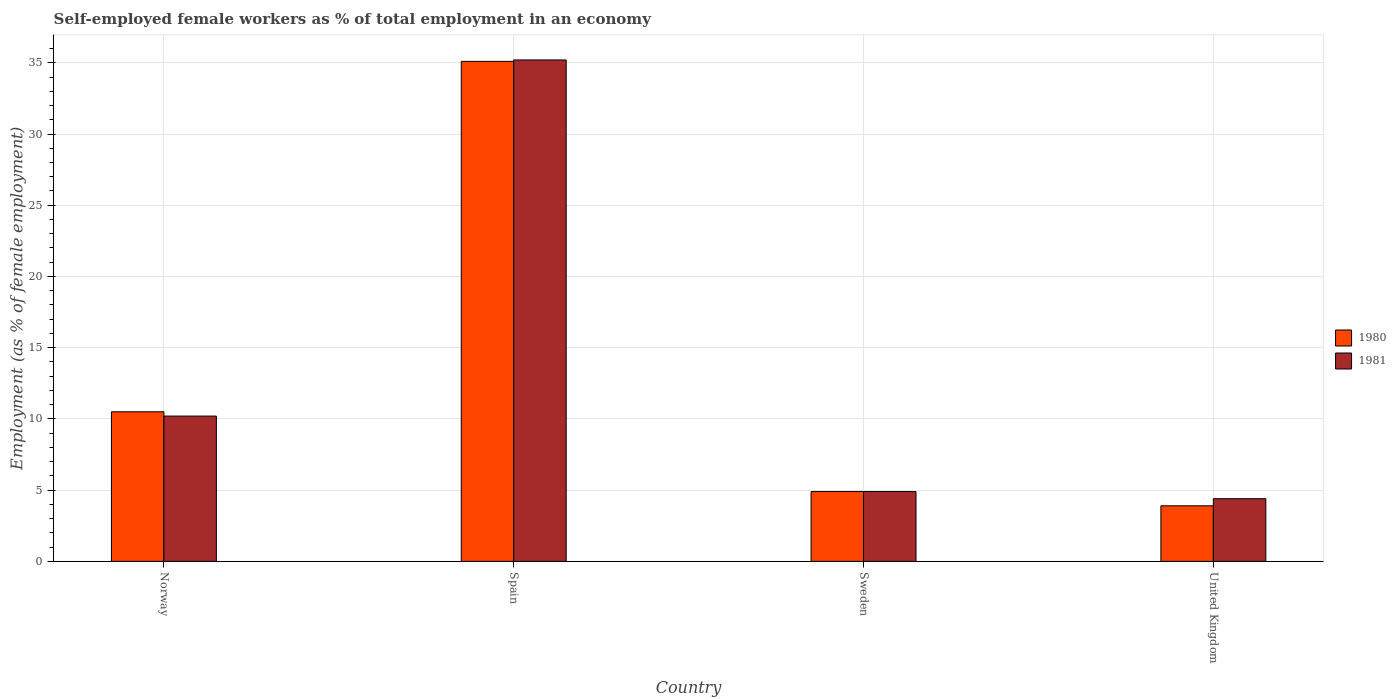How many groups of bars are there?
Your response must be concise. 4. Are the number of bars per tick equal to the number of legend labels?
Ensure brevity in your answer.  Yes. How many bars are there on the 3rd tick from the left?
Ensure brevity in your answer.  2. What is the label of the 4th group of bars from the left?
Provide a succinct answer. United Kingdom. What is the percentage of self-employed female workers in 1980 in United Kingdom?
Offer a very short reply. 3.9. Across all countries, what is the maximum percentage of self-employed female workers in 1981?
Make the answer very short. 35.2. Across all countries, what is the minimum percentage of self-employed female workers in 1980?
Give a very brief answer. 3.9. In which country was the percentage of self-employed female workers in 1981 minimum?
Give a very brief answer. United Kingdom. What is the total percentage of self-employed female workers in 1981 in the graph?
Your response must be concise. 54.7. What is the difference between the percentage of self-employed female workers in 1980 in Spain and that in Sweden?
Keep it short and to the point. 30.2. What is the difference between the percentage of self-employed female workers in 1980 in Sweden and the percentage of self-employed female workers in 1981 in Norway?
Offer a very short reply. -5.3. What is the average percentage of self-employed female workers in 1981 per country?
Make the answer very short. 13.68. What is the difference between the percentage of self-employed female workers of/in 1981 and percentage of self-employed female workers of/in 1980 in Norway?
Provide a short and direct response. -0.3. What is the ratio of the percentage of self-employed female workers in 1980 in Sweden to that in United Kingdom?
Your answer should be very brief. 1.26. What is the difference between the highest and the second highest percentage of self-employed female workers in 1981?
Make the answer very short. -25. What is the difference between the highest and the lowest percentage of self-employed female workers in 1980?
Provide a short and direct response. 31.2. What does the 1st bar from the left in Spain represents?
Provide a succinct answer. 1980. How many bars are there?
Your answer should be compact. 8. Are all the bars in the graph horizontal?
Ensure brevity in your answer.  No. How many countries are there in the graph?
Make the answer very short. 4. Does the graph contain grids?
Your response must be concise. Yes. How many legend labels are there?
Ensure brevity in your answer.  2. What is the title of the graph?
Your answer should be very brief. Self-employed female workers as % of total employment in an economy. Does "1965" appear as one of the legend labels in the graph?
Make the answer very short. No. What is the label or title of the Y-axis?
Your answer should be very brief. Employment (as % of female employment). What is the Employment (as % of female employment) of 1981 in Norway?
Keep it short and to the point. 10.2. What is the Employment (as % of female employment) of 1980 in Spain?
Your response must be concise. 35.1. What is the Employment (as % of female employment) in 1981 in Spain?
Keep it short and to the point. 35.2. What is the Employment (as % of female employment) in 1980 in Sweden?
Keep it short and to the point. 4.9. What is the Employment (as % of female employment) in 1981 in Sweden?
Provide a short and direct response. 4.9. What is the Employment (as % of female employment) in 1980 in United Kingdom?
Your answer should be compact. 3.9. What is the Employment (as % of female employment) in 1981 in United Kingdom?
Your answer should be very brief. 4.4. Across all countries, what is the maximum Employment (as % of female employment) of 1980?
Ensure brevity in your answer.  35.1. Across all countries, what is the maximum Employment (as % of female employment) of 1981?
Provide a succinct answer. 35.2. Across all countries, what is the minimum Employment (as % of female employment) in 1980?
Your answer should be compact. 3.9. Across all countries, what is the minimum Employment (as % of female employment) of 1981?
Offer a very short reply. 4.4. What is the total Employment (as % of female employment) in 1980 in the graph?
Your answer should be compact. 54.4. What is the total Employment (as % of female employment) of 1981 in the graph?
Make the answer very short. 54.7. What is the difference between the Employment (as % of female employment) of 1980 in Norway and that in Spain?
Provide a succinct answer. -24.6. What is the difference between the Employment (as % of female employment) in 1980 in Norway and that in Sweden?
Keep it short and to the point. 5.6. What is the difference between the Employment (as % of female employment) of 1980 in Spain and that in Sweden?
Provide a short and direct response. 30.2. What is the difference between the Employment (as % of female employment) in 1981 in Spain and that in Sweden?
Your answer should be compact. 30.3. What is the difference between the Employment (as % of female employment) of 1980 in Spain and that in United Kingdom?
Offer a very short reply. 31.2. What is the difference between the Employment (as % of female employment) in 1981 in Spain and that in United Kingdom?
Your answer should be compact. 30.8. What is the difference between the Employment (as % of female employment) of 1980 in Sweden and that in United Kingdom?
Offer a terse response. 1. What is the difference between the Employment (as % of female employment) in 1981 in Sweden and that in United Kingdom?
Provide a short and direct response. 0.5. What is the difference between the Employment (as % of female employment) of 1980 in Norway and the Employment (as % of female employment) of 1981 in Spain?
Your answer should be very brief. -24.7. What is the difference between the Employment (as % of female employment) in 1980 in Spain and the Employment (as % of female employment) in 1981 in Sweden?
Give a very brief answer. 30.2. What is the difference between the Employment (as % of female employment) of 1980 in Spain and the Employment (as % of female employment) of 1981 in United Kingdom?
Your answer should be very brief. 30.7. What is the difference between the Employment (as % of female employment) in 1980 in Sweden and the Employment (as % of female employment) in 1981 in United Kingdom?
Your answer should be very brief. 0.5. What is the average Employment (as % of female employment) of 1981 per country?
Ensure brevity in your answer.  13.68. What is the difference between the Employment (as % of female employment) in 1980 and Employment (as % of female employment) in 1981 in Norway?
Keep it short and to the point. 0.3. What is the difference between the Employment (as % of female employment) in 1980 and Employment (as % of female employment) in 1981 in United Kingdom?
Your answer should be very brief. -0.5. What is the ratio of the Employment (as % of female employment) of 1980 in Norway to that in Spain?
Provide a short and direct response. 0.3. What is the ratio of the Employment (as % of female employment) of 1981 in Norway to that in Spain?
Offer a very short reply. 0.29. What is the ratio of the Employment (as % of female employment) in 1980 in Norway to that in Sweden?
Keep it short and to the point. 2.14. What is the ratio of the Employment (as % of female employment) of 1981 in Norway to that in Sweden?
Your answer should be compact. 2.08. What is the ratio of the Employment (as % of female employment) of 1980 in Norway to that in United Kingdom?
Give a very brief answer. 2.69. What is the ratio of the Employment (as % of female employment) of 1981 in Norway to that in United Kingdom?
Your answer should be very brief. 2.32. What is the ratio of the Employment (as % of female employment) in 1980 in Spain to that in Sweden?
Give a very brief answer. 7.16. What is the ratio of the Employment (as % of female employment) in 1981 in Spain to that in Sweden?
Your answer should be very brief. 7.18. What is the ratio of the Employment (as % of female employment) in 1980 in Spain to that in United Kingdom?
Ensure brevity in your answer.  9. What is the ratio of the Employment (as % of female employment) of 1981 in Spain to that in United Kingdom?
Give a very brief answer. 8. What is the ratio of the Employment (as % of female employment) of 1980 in Sweden to that in United Kingdom?
Ensure brevity in your answer.  1.26. What is the ratio of the Employment (as % of female employment) in 1981 in Sweden to that in United Kingdom?
Provide a succinct answer. 1.11. What is the difference between the highest and the second highest Employment (as % of female employment) in 1980?
Provide a short and direct response. 24.6. What is the difference between the highest and the second highest Employment (as % of female employment) in 1981?
Ensure brevity in your answer.  25. What is the difference between the highest and the lowest Employment (as % of female employment) in 1980?
Ensure brevity in your answer.  31.2. What is the difference between the highest and the lowest Employment (as % of female employment) in 1981?
Your answer should be very brief. 30.8. 